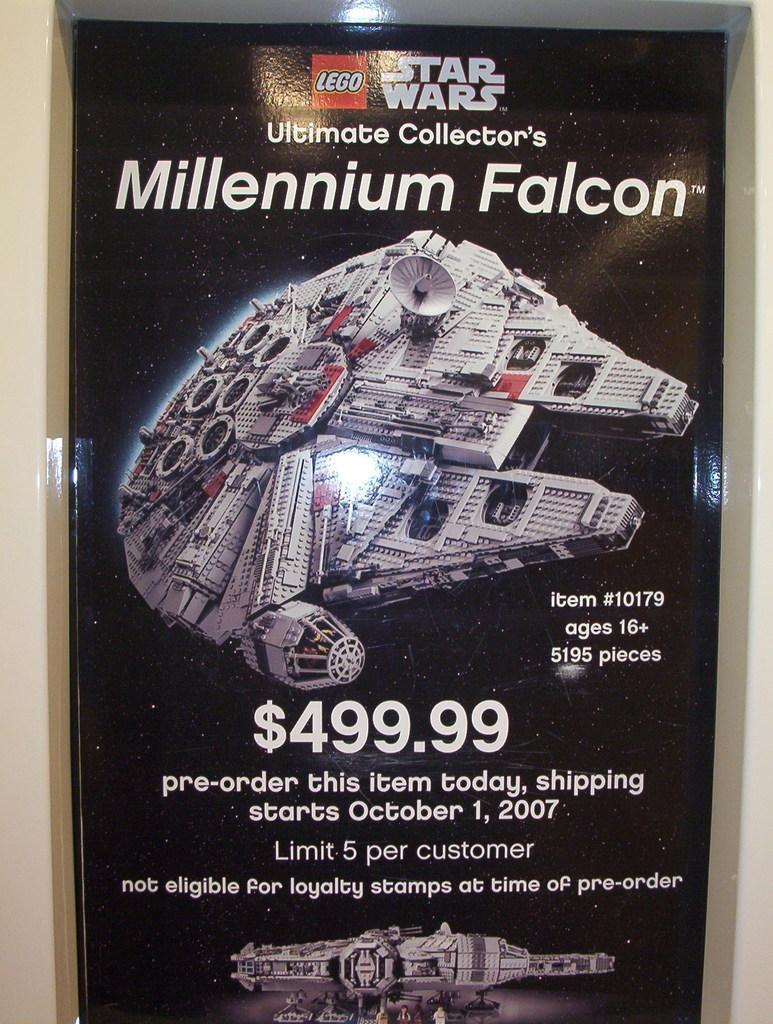<image>
Relay a brief, clear account of the picture shown. A flyer for Lego Star Wars Millennium Falcon that is on sale for $499.99, which releases on October 1, 2007. 